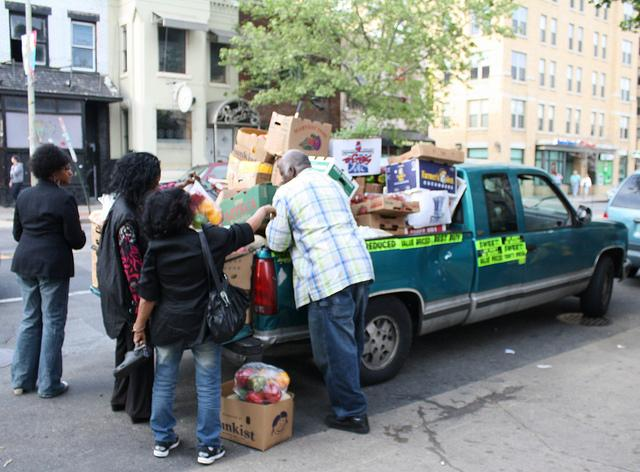Why is there green tape on the pickup?

Choices:
A) repairs
B) vandalism
C) advertising
D) decorative advertising 